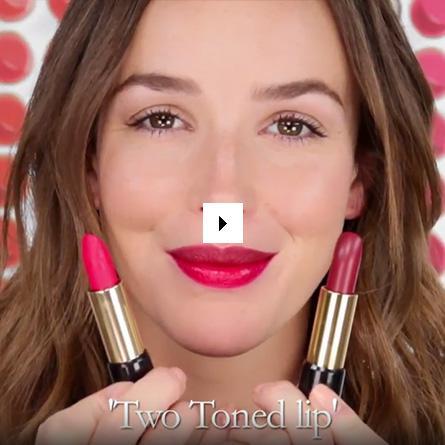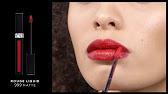The first image is the image on the left, the second image is the image on the right. Considering the images on both sides, is "An image shows an Asian model with lavender-tinted lips and thin black straps on her shoulders." valid? Answer yes or no. No. 